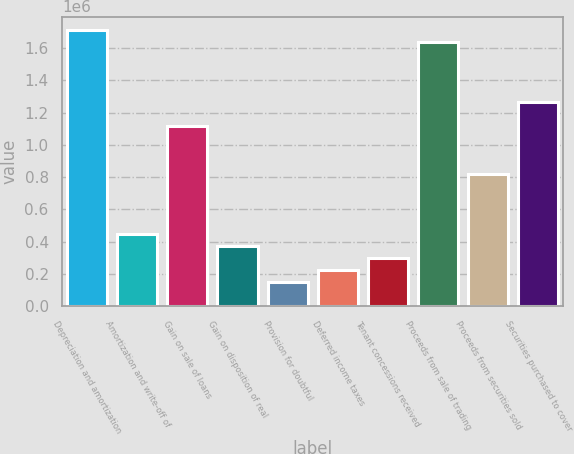Convert chart to OTSL. <chart><loc_0><loc_0><loc_500><loc_500><bar_chart><fcel>Depreciation and amortization<fcel>Amortization and write-off of<fcel>Gain on sale of loans<fcel>Gain on disposition of real<fcel>Provision for doubtful<fcel>Deferred income taxes<fcel>Tenant concessions received<fcel>Proceeds from sale of trading<fcel>Proceeds from securities sold<fcel>Securities purchased to cover<nl><fcel>1.71042e+06<fcel>448088<fcel>1.11638e+06<fcel>373834<fcel>151069<fcel>225324<fcel>299579<fcel>1.63617e+06<fcel>819363<fcel>1.26489e+06<nl></chart> 